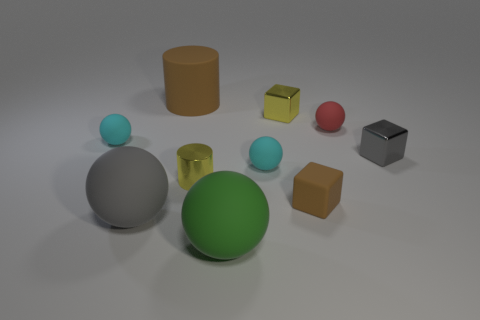Are there more large yellow metallic objects than cylinders?
Provide a succinct answer. No. Does the cyan sphere on the right side of the big matte cylinder have the same material as the yellow cylinder?
Give a very brief answer. No. Is the number of tiny purple metallic cylinders less than the number of small red things?
Provide a succinct answer. Yes. Is there a big gray sphere that is behind the cylinder in front of the cyan matte thing that is on the left side of the gray sphere?
Your response must be concise. No. There is a big thing behind the shiny cylinder; does it have the same shape as the large gray thing?
Offer a very short reply. No. Is the number of tiny matte things that are to the left of the large brown matte cylinder greater than the number of matte cylinders?
Provide a short and direct response. No. There is a tiny ball that is in front of the tiny gray metal object; does it have the same color as the matte cylinder?
Ensure brevity in your answer.  No. Is there any other thing that has the same color as the matte cube?
Give a very brief answer. Yes. The big object behind the tiny cyan matte thing in front of the small object right of the red rubber object is what color?
Your response must be concise. Brown. Do the gray ball and the green matte object have the same size?
Give a very brief answer. Yes. 